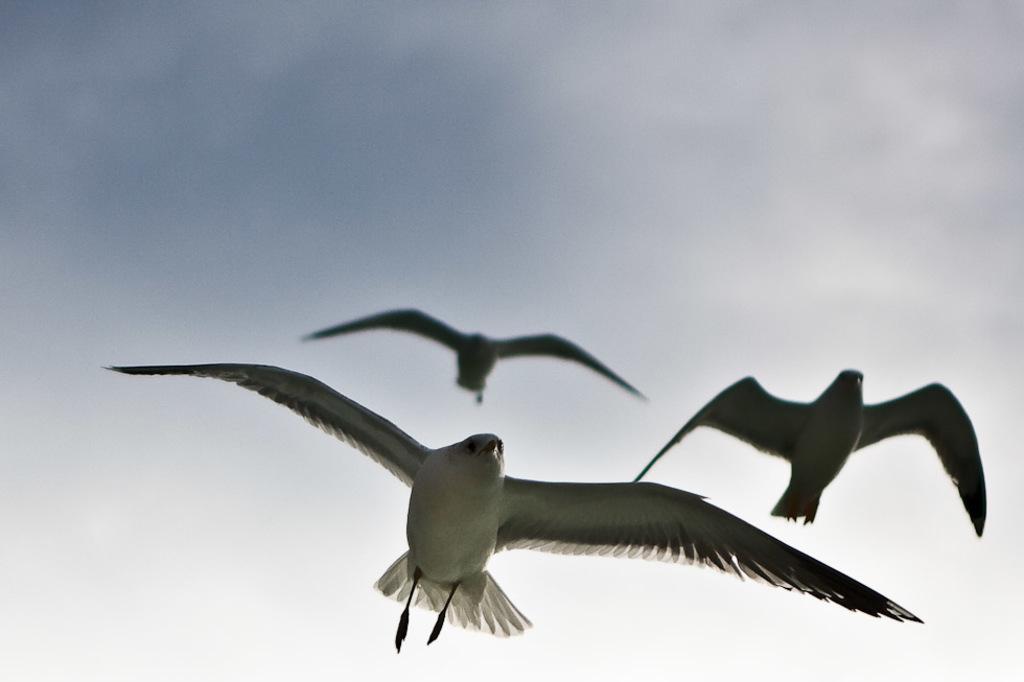Could you give a brief overview of what you see in this image? In this image we can see three birds flying and in the background there is the sky. 